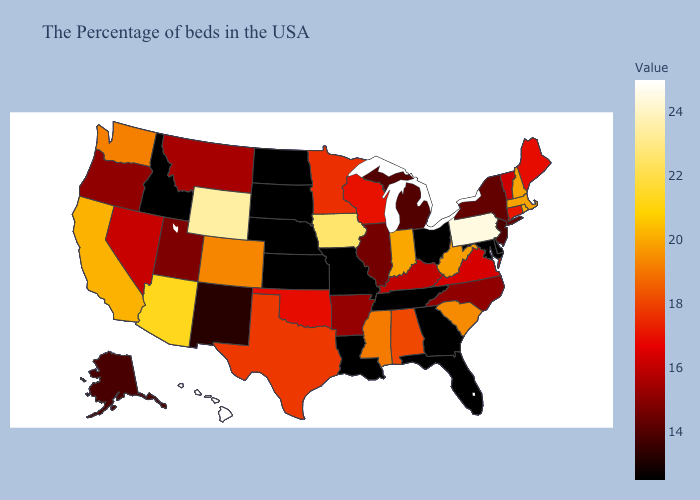Which states have the lowest value in the MidWest?
Short answer required. Ohio, Missouri, Kansas, Nebraska, South Dakota, North Dakota. Does Hawaii have the highest value in the USA?
Quick response, please. Yes. Does Iowa have the highest value in the MidWest?
Answer briefly. Yes. Among the states that border Oklahoma , which have the lowest value?
Answer briefly. Missouri, Kansas. 